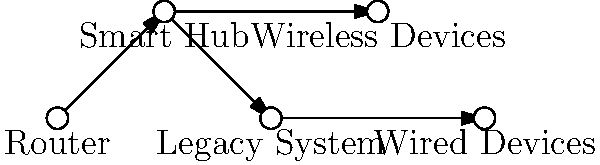In the network diagram for integrating legacy wired systems with new wireless smart home devices, which component serves as the central point of communication between the router, legacy systems, and wireless devices? To determine the central point of communication in this smart home network integration, let's analyze the components and their connections:

1. Router: This is the entry point for internet connectivity but doesn't directly connect to all devices.

2. Smart Hub: This component is directly connected to:
   a) The router (for internet access)
   b) The legacy system (integrating old technology)
   c) Wireless devices (new smart home technology)

3. Legacy System: Connected to the Smart Hub and wired devices, but not directly to wireless devices or the router.

4. Wireless Devices: Connected only to the Smart Hub.

5. Wired Devices: Connected to the Legacy System, not directly to the Smart Hub or router.

The Smart Hub is the only component that has direct connections to the router, legacy systems, and wireless devices. It acts as a bridge between old and new technologies, allowing for seamless integration and communication between all parts of the system.

Therefore, the Smart Hub serves as the central point of communication in this network diagram.
Answer: Smart Hub 